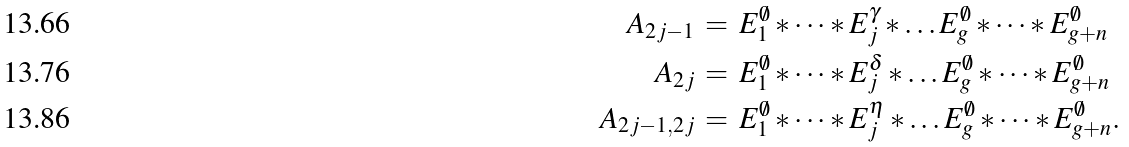Convert formula to latex. <formula><loc_0><loc_0><loc_500><loc_500>A _ { 2 j - 1 } & \, = \, E _ { 1 } ^ { \emptyset } \ast \dots \ast E _ { j } ^ { \gamma } \ast \dots E _ { g } ^ { \emptyset } \ast \dots \ast E _ { g + n } ^ { \emptyset } \\ A _ { 2 j } & \, = \, E _ { 1 } ^ { \emptyset } \ast \dots \ast E _ { j } ^ { \delta } \ast \dots E _ { g } ^ { \emptyset } \ast \dots \ast E _ { g + n } ^ { \emptyset } \\ A _ { 2 j - 1 , 2 j } & \, = \, E _ { 1 } ^ { \emptyset } \ast \dots \ast E _ { j } ^ { \eta } \ast \dots E _ { g } ^ { \emptyset } \ast \dots \ast E _ { g + n } ^ { \emptyset } .</formula> 